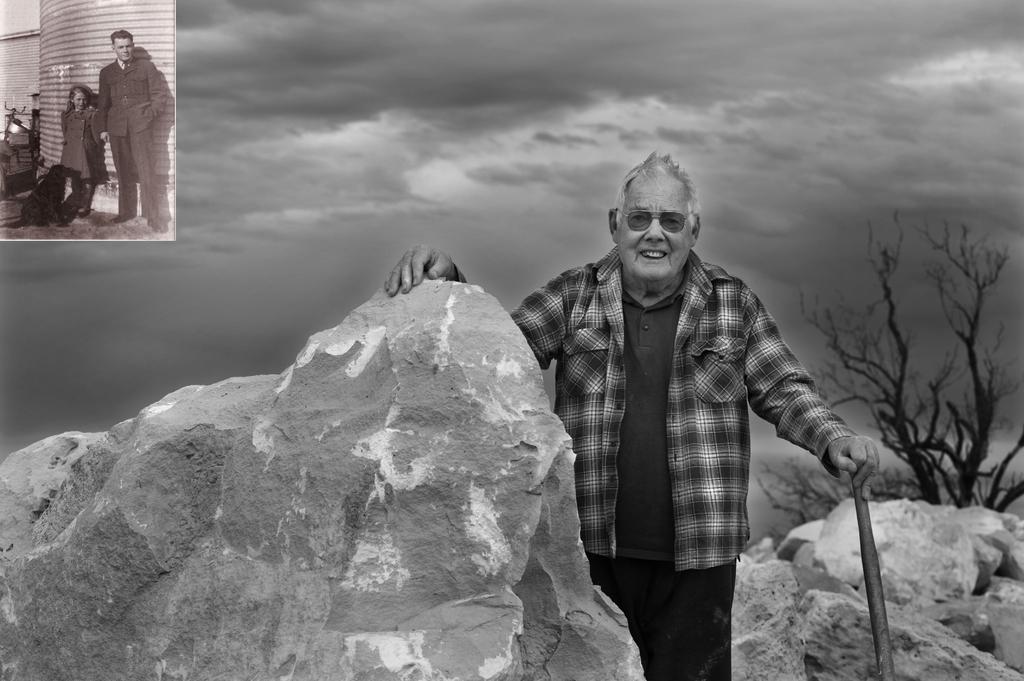Can you describe this image briefly? In the image we can see there is a man standing and holding a stick in his hand. There are rocks and behind there is a tree. On the top there is small picture on which a man standing with a girl and there is dog beside them. The image is in black and white colour. 